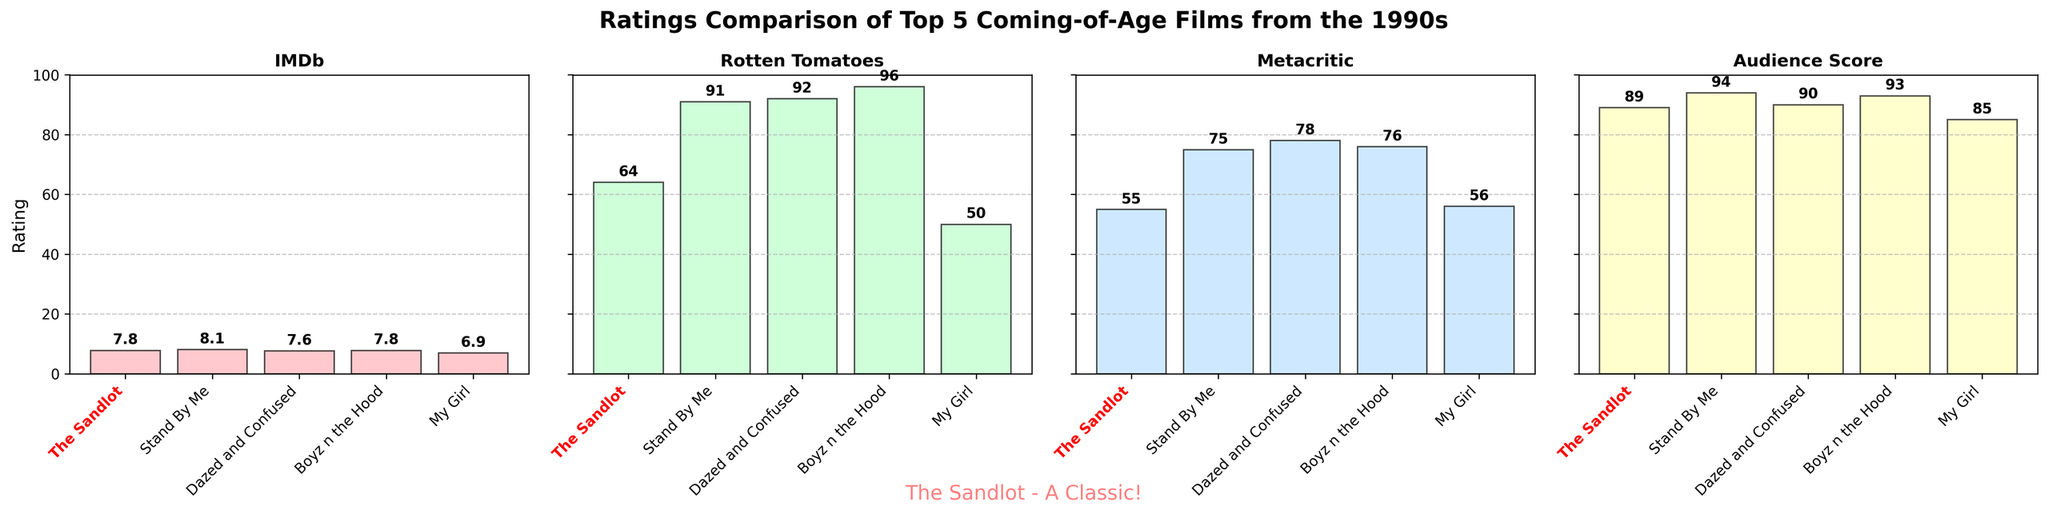What's the highest IMDb rating among the movies? By looking at the IMDb subplot, we can see the tallest bar represents Stand By Me with a rating of 8.1.
Answer: 8.1 How does The Sandlot’s Audience Score compare with Boyz n the Hood’s Audience Score? The Sandlot has an Audience Score of 89 while Boyz n the Hood has 93. 93 is greater than 89.
Answer: Boyz n the Hood’s score is higher Which movie has the lowest Rotten Tomatoes score and what is it? In the Rotten Tomatoes subplot, the shortest bar represents My Girl, with a score of 50.
Answer: My Girl with 50 What is the difference between the Metacritic scores of The Sandlot and Boyz n the Hood? According to the Metacritic subplot, The Sandlot has a score of 55 and Boyz n the Hood has 76. The difference is 76 - 55 = 21.
Answer: 21 What is the average IMDb rating for the five movies? Adding up all IMDb ratings: 7.8 + 8.1 + 7.6 + 7.8 + 6.9 = 38.2. Dividing by 5 gives 38.2 / 5 = 7.64.
Answer: 7.64 Which movie has the most balanced ratings across all four subplots? Boyz n the Hood has consistently high ratings across all plots: IMDb (7.8), Rotten Tomatoes (96), Metacritic (76), and Audience Score (93).
Answer: Boyz n the Hood Identify the movie highlighted in red and bold on the x-axis. The subplot visually highlights The Sandlot in red and bold on the x-axis.
Answer: The Sandlot What’s the range of Metacritic scores for these movies? The highest Metacritic score is 78 (Dazed and Confused) and the lowest is 55 (The Sandlot). The range is 78 - 55 = 23.
Answer: 23 Which movie has the closest IMDb rating to 7.8 besides The Sandlot? According to the IMDb subplot, Boyz n the Hood also has an IMDb rating of 7.8.
Answer: Boyz n the Hood How much higher is Stand By Me's Rotten Tomatoes score compared to The Sandlot’s? Stand By Me has a Rotten Tomatoes score of 91 while The Sandlot has 64. The difference is 91 - 64 = 27.
Answer: 27 